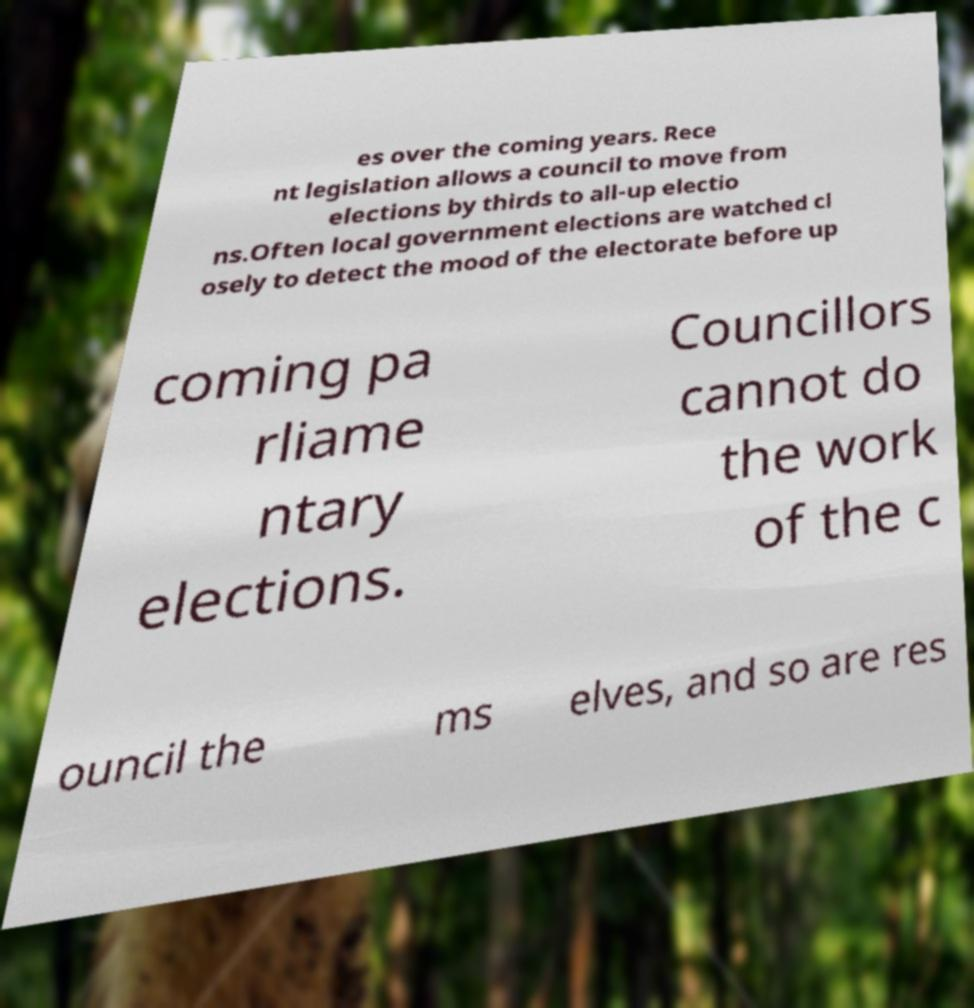Could you assist in decoding the text presented in this image and type it out clearly? es over the coming years. Rece nt legislation allows a council to move from elections by thirds to all-up electio ns.Often local government elections are watched cl osely to detect the mood of the electorate before up coming pa rliame ntary elections. Councillors cannot do the work of the c ouncil the ms elves, and so are res 